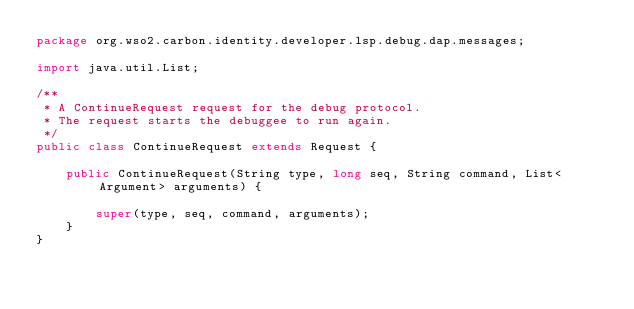<code> <loc_0><loc_0><loc_500><loc_500><_Java_>package org.wso2.carbon.identity.developer.lsp.debug.dap.messages;

import java.util.List;

/**
 * A ContinueRequest request for the debug protocol.
 * The request starts the debuggee to run again.
 */
public class ContinueRequest extends Request {

    public ContinueRequest(String type, long seq, String command, List<Argument> arguments) {

        super(type, seq, command, arguments);
    }
}
</code> 